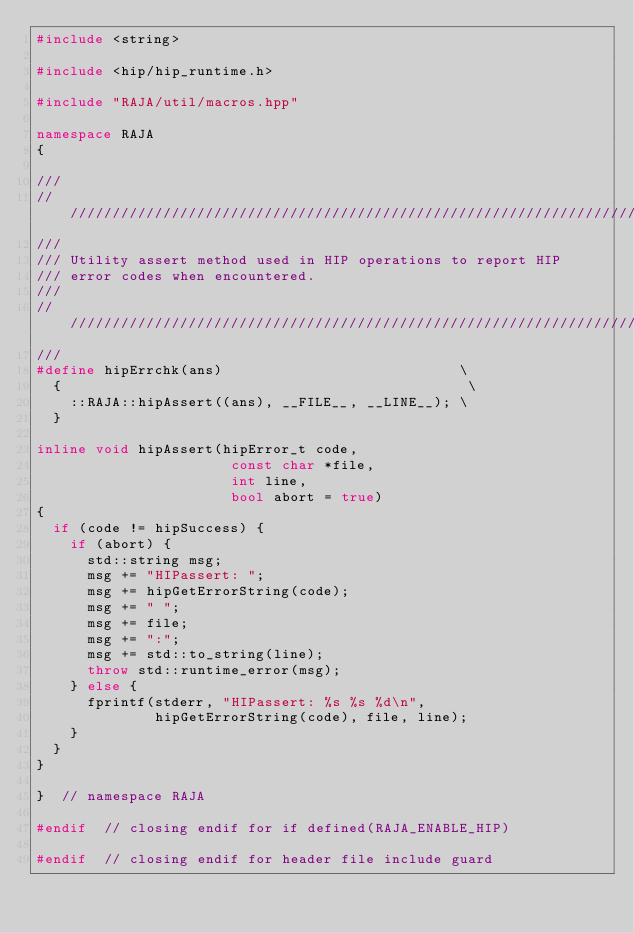Convert code to text. <code><loc_0><loc_0><loc_500><loc_500><_C++_>#include <string>

#include <hip/hip_runtime.h>

#include "RAJA/util/macros.hpp"

namespace RAJA
{

///
///////////////////////////////////////////////////////////////////////
///
/// Utility assert method used in HIP operations to report HIP
/// error codes when encountered.
///
///////////////////////////////////////////////////////////////////////
///
#define hipErrchk(ans)                            \
  {                                                \
    ::RAJA::hipAssert((ans), __FILE__, __LINE__); \
  }

inline void hipAssert(hipError_t code,
                       const char *file,
                       int line,
                       bool abort = true)
{
  if (code != hipSuccess) {
    if (abort) {
      std::string msg;
      msg += "HIPassert: ";
      msg += hipGetErrorString(code);
      msg += " ";
      msg += file;
      msg += ":";
      msg += std::to_string(line);
      throw std::runtime_error(msg);
    } else {
      fprintf(stderr, "HIPassert: %s %s %d\n",
              hipGetErrorString(code), file, line);
    }
  }
}

}  // namespace RAJA

#endif  // closing endif for if defined(RAJA_ENABLE_HIP)

#endif  // closing endif for header file include guard
</code> 